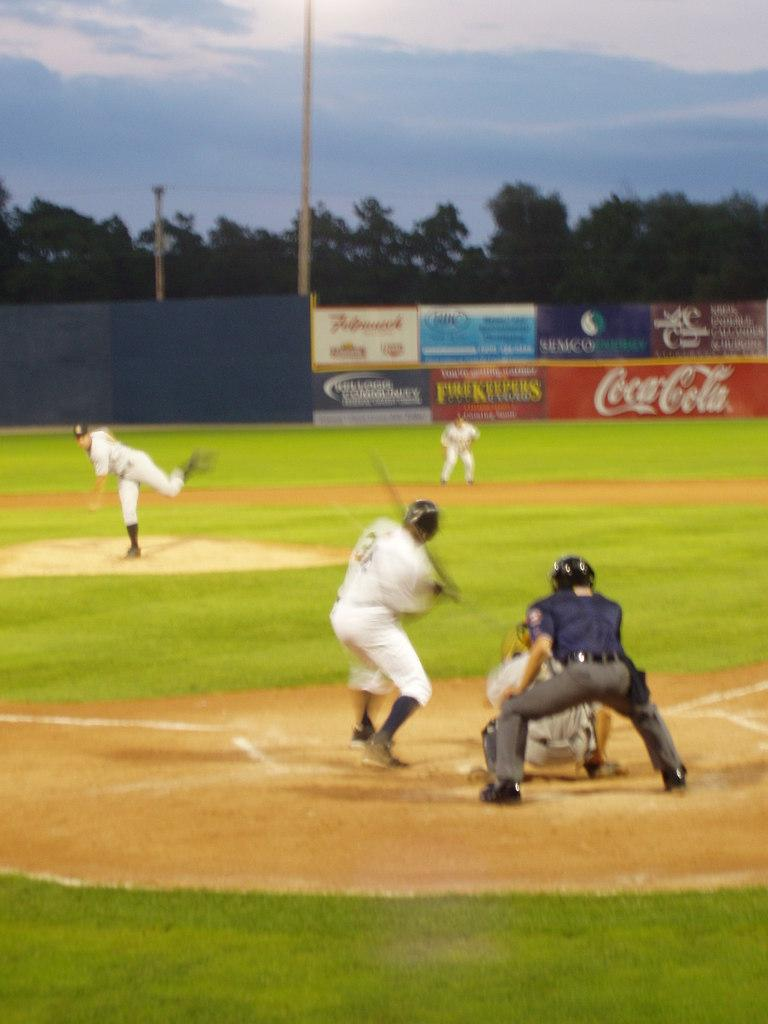<image>
Write a terse but informative summary of the picture. One of the sponsors in the baseball field is Coca-Cola. 